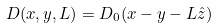Convert formula to latex. <formula><loc_0><loc_0><loc_500><loc_500>D ( { x } , { y } , L ) = D _ { 0 } ( { x } - { y } - L \hat { z } )</formula> 